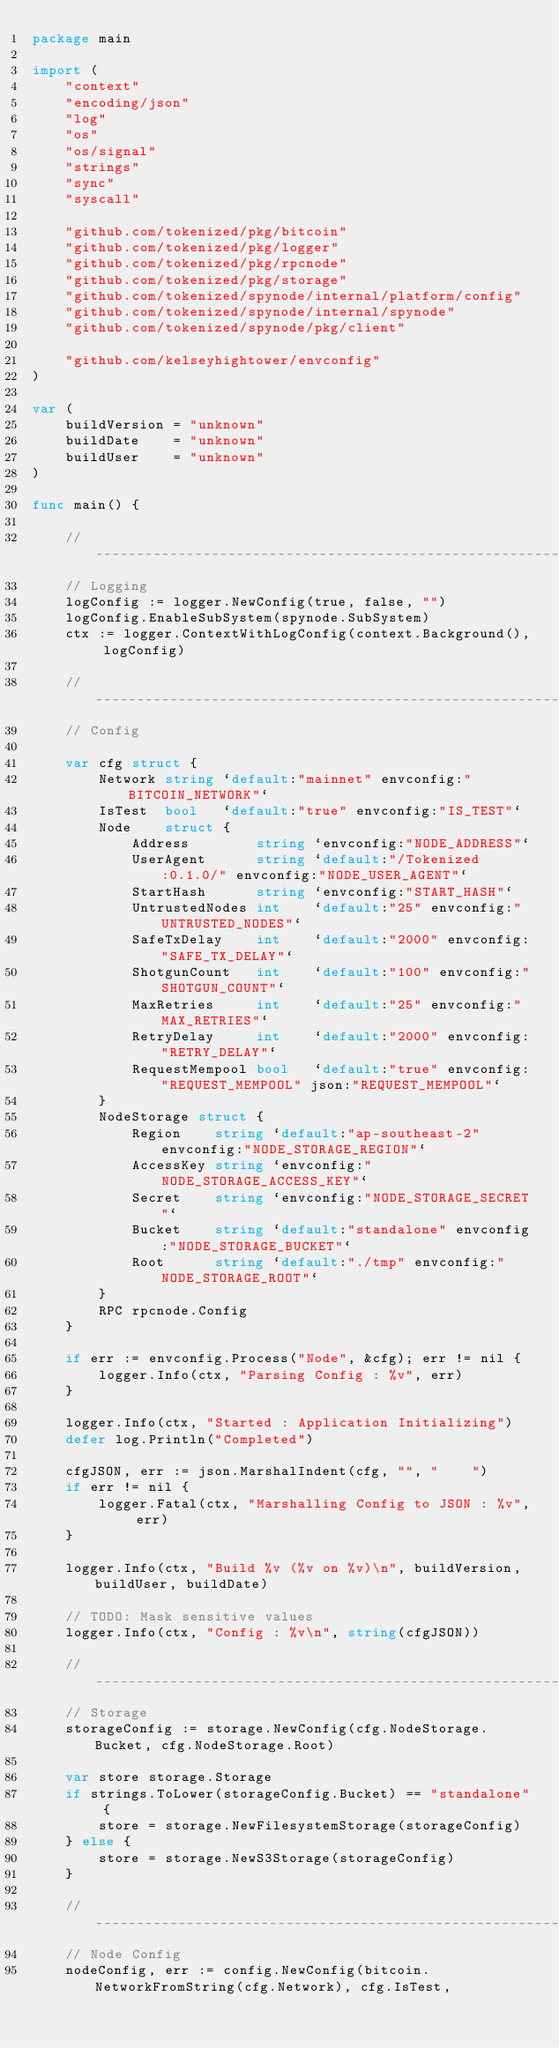Convert code to text. <code><loc_0><loc_0><loc_500><loc_500><_Go_>package main

import (
	"context"
	"encoding/json"
	"log"
	"os"
	"os/signal"
	"strings"
	"sync"
	"syscall"

	"github.com/tokenized/pkg/bitcoin"
	"github.com/tokenized/pkg/logger"
	"github.com/tokenized/pkg/rpcnode"
	"github.com/tokenized/pkg/storage"
	"github.com/tokenized/spynode/internal/platform/config"
	"github.com/tokenized/spynode/internal/spynode"
	"github.com/tokenized/spynode/pkg/client"

	"github.com/kelseyhightower/envconfig"
)

var (
	buildVersion = "unknown"
	buildDate    = "unknown"
	buildUser    = "unknown"
)

func main() {

	// -------------------------------------------------------------------------
	// Logging
	logConfig := logger.NewConfig(true, false, "")
	logConfig.EnableSubSystem(spynode.SubSystem)
	ctx := logger.ContextWithLogConfig(context.Background(), logConfig)

	// -------------------------------------------------------------------------
	// Config

	var cfg struct {
		Network string `default:"mainnet" envconfig:"BITCOIN_NETWORK"`
		IsTest  bool   `default:"true" envconfig:"IS_TEST"`
		Node    struct {
			Address        string `envconfig:"NODE_ADDRESS"`
			UserAgent      string `default:"/Tokenized:0.1.0/" envconfig:"NODE_USER_AGENT"`
			StartHash      string `envconfig:"START_HASH"`
			UntrustedNodes int    `default:"25" envconfig:"UNTRUSTED_NODES"`
			SafeTxDelay    int    `default:"2000" envconfig:"SAFE_TX_DELAY"`
			ShotgunCount   int    `default:"100" envconfig:"SHOTGUN_COUNT"`
			MaxRetries     int    `default:"25" envconfig:"MAX_RETRIES"`
			RetryDelay     int    `default:"2000" envconfig:"RETRY_DELAY"`
			RequestMempool bool   `default:"true" envconfig:"REQUEST_MEMPOOL" json:"REQUEST_MEMPOOL"`
		}
		NodeStorage struct {
			Region    string `default:"ap-southeast-2" envconfig:"NODE_STORAGE_REGION"`
			AccessKey string `envconfig:"NODE_STORAGE_ACCESS_KEY"`
			Secret    string `envconfig:"NODE_STORAGE_SECRET"`
			Bucket    string `default:"standalone" envconfig:"NODE_STORAGE_BUCKET"`
			Root      string `default:"./tmp" envconfig:"NODE_STORAGE_ROOT"`
		}
		RPC rpcnode.Config
	}

	if err := envconfig.Process("Node", &cfg); err != nil {
		logger.Info(ctx, "Parsing Config : %v", err)
	}

	logger.Info(ctx, "Started : Application Initializing")
	defer log.Println("Completed")

	cfgJSON, err := json.MarshalIndent(cfg, "", "    ")
	if err != nil {
		logger.Fatal(ctx, "Marshalling Config to JSON : %v", err)
	}

	logger.Info(ctx, "Build %v (%v on %v)\n", buildVersion, buildUser, buildDate)

	// TODO: Mask sensitive values
	logger.Info(ctx, "Config : %v\n", string(cfgJSON))

	// -------------------------------------------------------------------------
	// Storage
	storageConfig := storage.NewConfig(cfg.NodeStorage.Bucket, cfg.NodeStorage.Root)

	var store storage.Storage
	if strings.ToLower(storageConfig.Bucket) == "standalone" {
		store = storage.NewFilesystemStorage(storageConfig)
	} else {
		store = storage.NewS3Storage(storageConfig)
	}

	// -------------------------------------------------------------------------
	// Node Config
	nodeConfig, err := config.NewConfig(bitcoin.NetworkFromString(cfg.Network), cfg.IsTest,</code> 